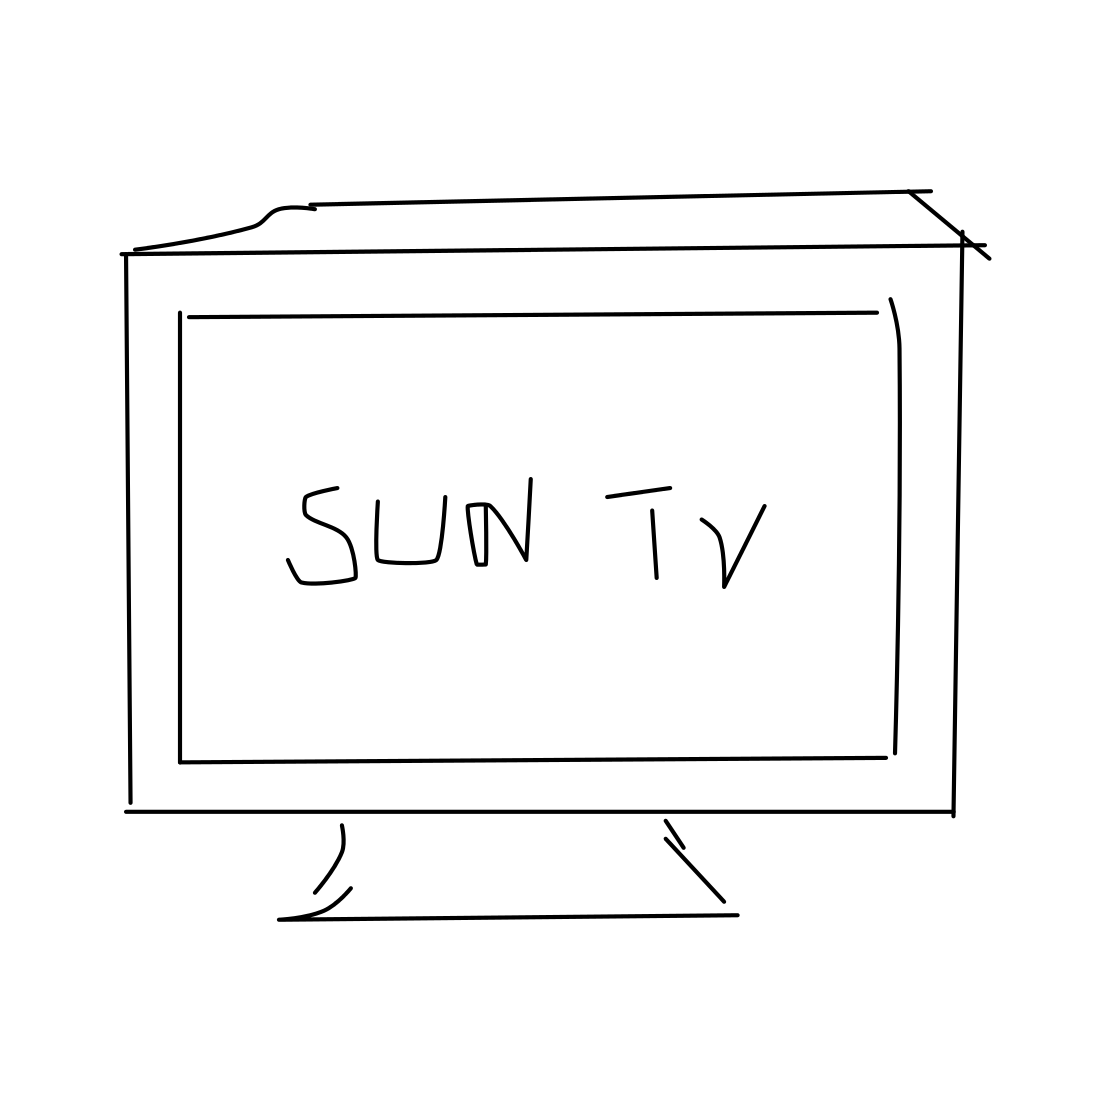Is this a tv in the image? Yes 